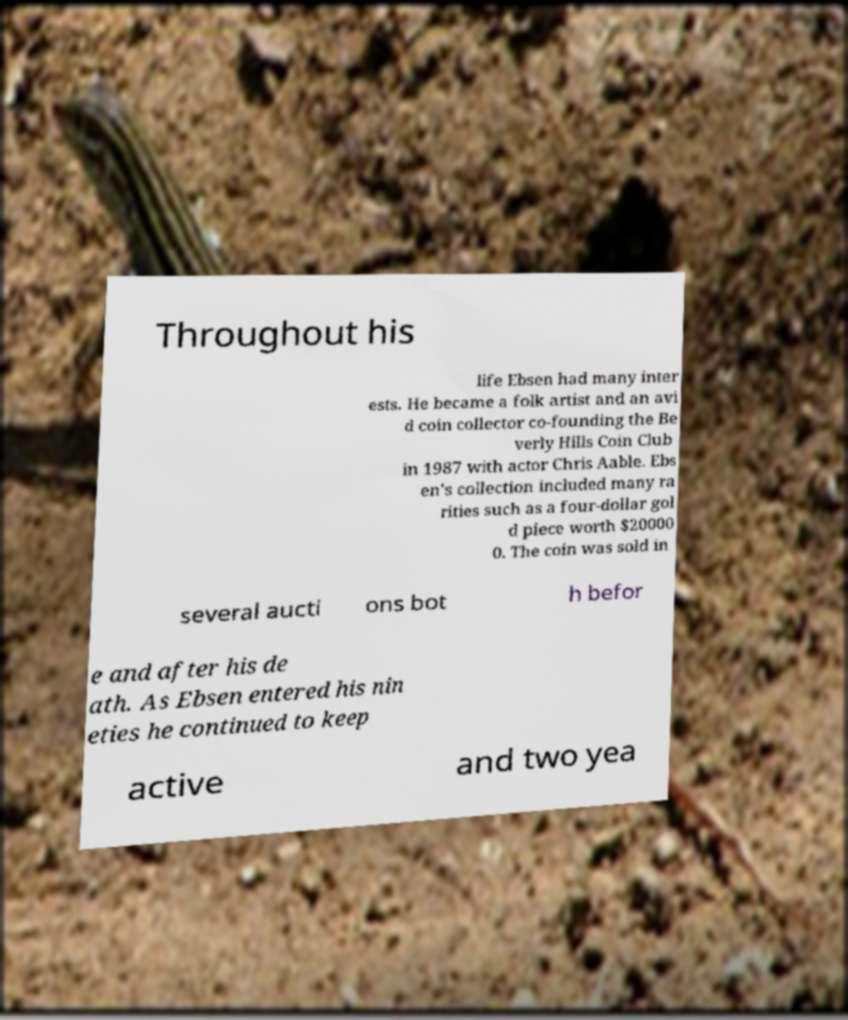Please identify and transcribe the text found in this image. Throughout his life Ebsen had many inter ests. He became a folk artist and an avi d coin collector co-founding the Be verly Hills Coin Club in 1987 with actor Chris Aable. Ebs en's collection included many ra rities such as a four-dollar gol d piece worth $20000 0. The coin was sold in several aucti ons bot h befor e and after his de ath. As Ebsen entered his nin eties he continued to keep active and two yea 